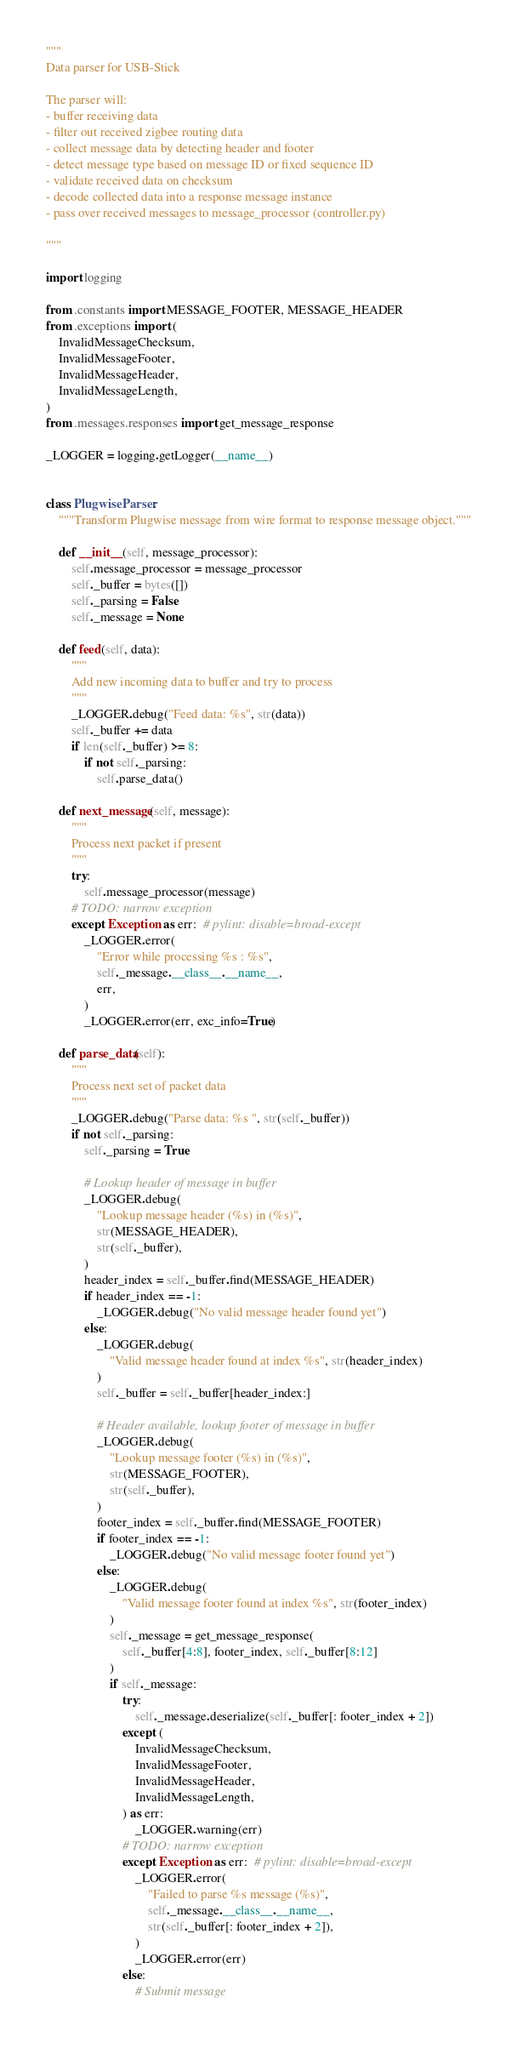<code> <loc_0><loc_0><loc_500><loc_500><_Python_>"""
Data parser for USB-Stick

The parser will:
- buffer receiving data
- filter out received zigbee routing data
- collect message data by detecting header and footer
- detect message type based on message ID or fixed sequence ID
- validate received data on checksum
- decode collected data into a response message instance
- pass over received messages to message_processor (controller.py)

"""

import logging

from .constants import MESSAGE_FOOTER, MESSAGE_HEADER
from .exceptions import (
    InvalidMessageChecksum,
    InvalidMessageFooter,
    InvalidMessageHeader,
    InvalidMessageLength,
)
from .messages.responses import get_message_response

_LOGGER = logging.getLogger(__name__)


class PlugwiseParser:
    """Transform Plugwise message from wire format to response message object."""

    def __init__(self, message_processor):
        self.message_processor = message_processor
        self._buffer = bytes([])
        self._parsing = False
        self._message = None

    def feed(self, data):
        """
        Add new incoming data to buffer and try to process
        """
        _LOGGER.debug("Feed data: %s", str(data))
        self._buffer += data
        if len(self._buffer) >= 8:
            if not self._parsing:
                self.parse_data()

    def next_message(self, message):
        """
        Process next packet if present
        """
        try:
            self.message_processor(message)
        # TODO: narrow exception
        except Exception as err:  # pylint: disable=broad-except
            _LOGGER.error(
                "Error while processing %s : %s",
                self._message.__class__.__name__,
                err,
            )
            _LOGGER.error(err, exc_info=True)

    def parse_data(self):
        """
        Process next set of packet data
        """
        _LOGGER.debug("Parse data: %s ", str(self._buffer))
        if not self._parsing:
            self._parsing = True

            # Lookup header of message in buffer
            _LOGGER.debug(
                "Lookup message header (%s) in (%s)",
                str(MESSAGE_HEADER),
                str(self._buffer),
            )
            header_index = self._buffer.find(MESSAGE_HEADER)
            if header_index == -1:
                _LOGGER.debug("No valid message header found yet")
            else:
                _LOGGER.debug(
                    "Valid message header found at index %s", str(header_index)
                )
                self._buffer = self._buffer[header_index:]

                # Header available, lookup footer of message in buffer
                _LOGGER.debug(
                    "Lookup message footer (%s) in (%s)",
                    str(MESSAGE_FOOTER),
                    str(self._buffer),
                )
                footer_index = self._buffer.find(MESSAGE_FOOTER)
                if footer_index == -1:
                    _LOGGER.debug("No valid message footer found yet")
                else:
                    _LOGGER.debug(
                        "Valid message footer found at index %s", str(footer_index)
                    )
                    self._message = get_message_response(
                        self._buffer[4:8], footer_index, self._buffer[8:12]
                    )
                    if self._message:
                        try:
                            self._message.deserialize(self._buffer[: footer_index + 2])
                        except (
                            InvalidMessageChecksum,
                            InvalidMessageFooter,
                            InvalidMessageHeader,
                            InvalidMessageLength,
                        ) as err:
                            _LOGGER.warning(err)
                        # TODO: narrow exception
                        except Exception as err:  # pylint: disable=broad-except
                            _LOGGER.error(
                                "Failed to parse %s message (%s)",
                                self._message.__class__.__name__,
                                str(self._buffer[: footer_index + 2]),
                            )
                            _LOGGER.error(err)
                        else:
                            # Submit message</code> 